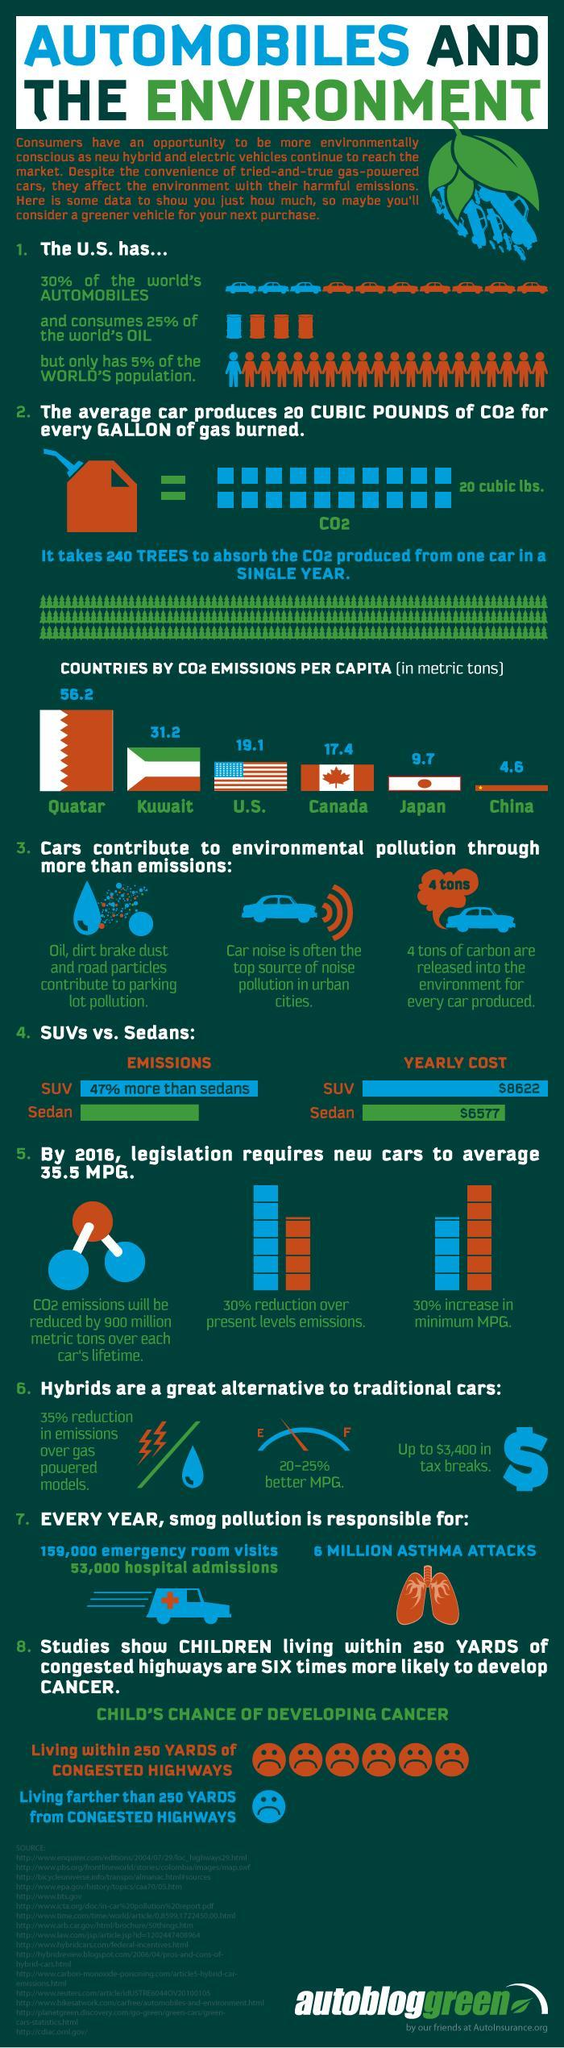What percentage of the world's oil is not consumed by the US?
Answer the question with a short phrase. 75% What percentage of the world's automobiles are not in the US? 70% What is the CO2 emission per capita in Canada? 17.4 What is the CO2 emission per capita in Kuwait? 31.2 What percentage of the world's population is not in the US? 95% 